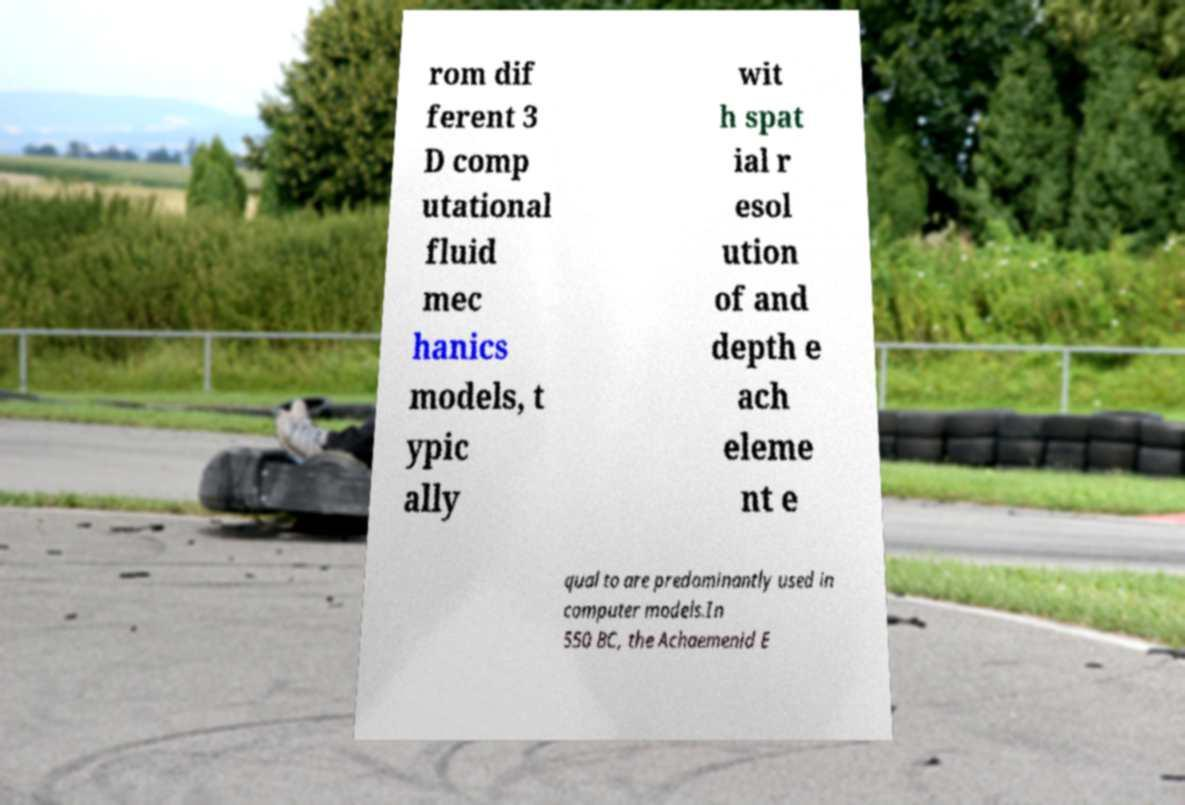Could you assist in decoding the text presented in this image and type it out clearly? rom dif ferent 3 D comp utational fluid mec hanics models, t ypic ally wit h spat ial r esol ution of and depth e ach eleme nt e qual to are predominantly used in computer models.In 550 BC, the Achaemenid E 